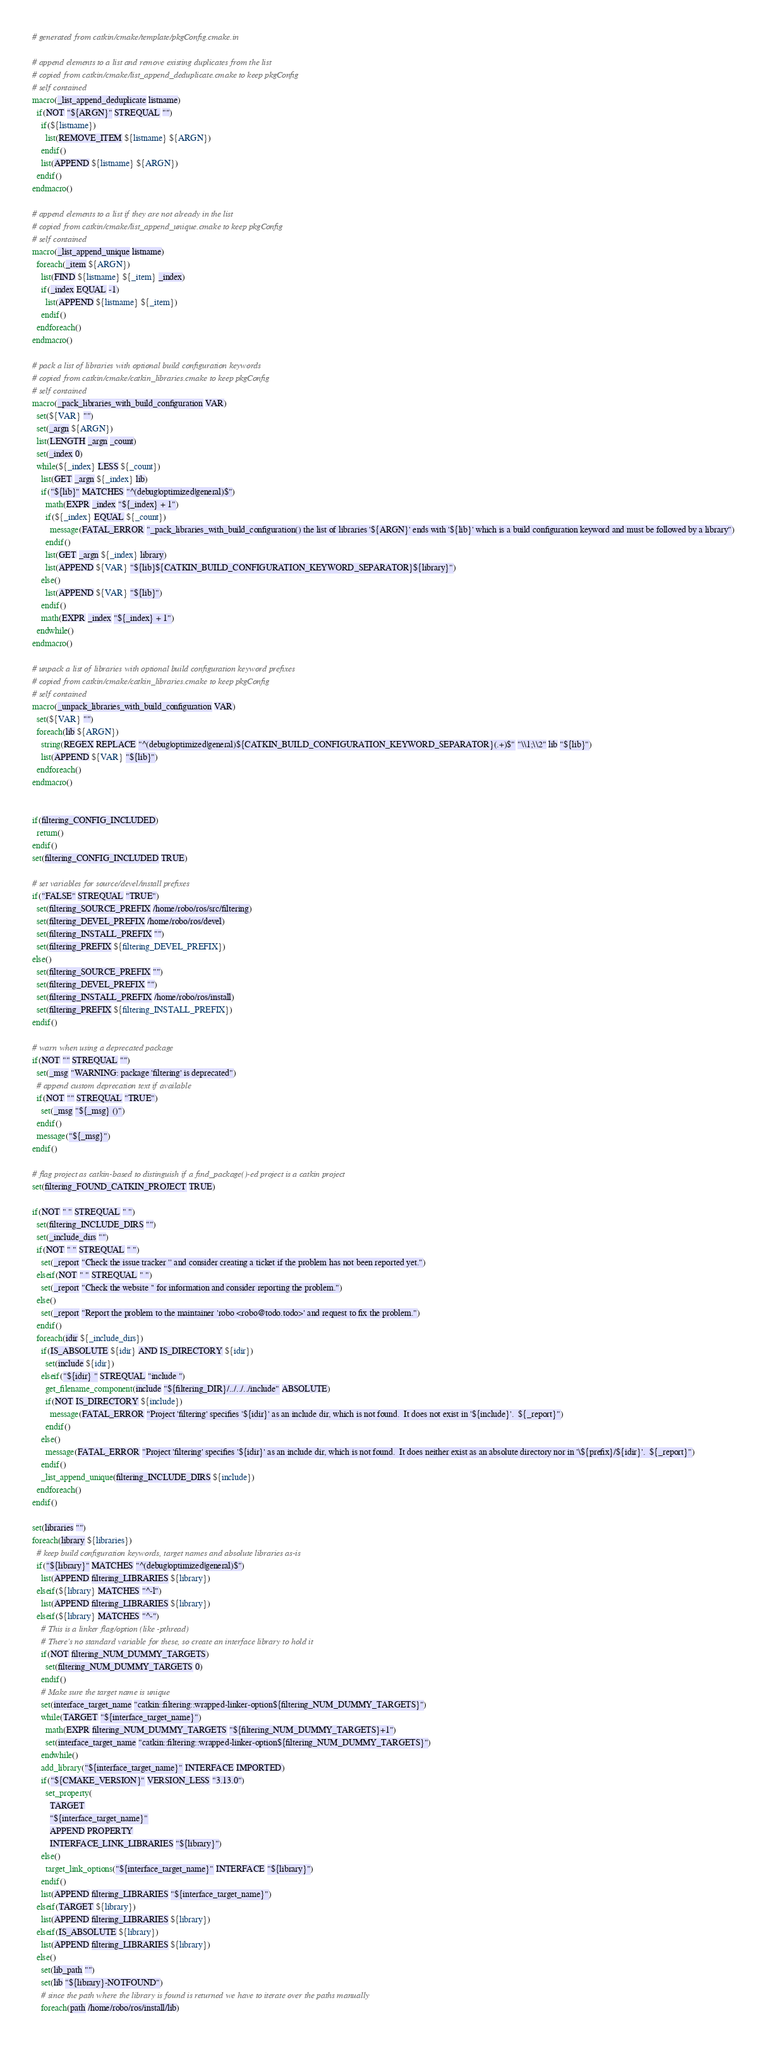Convert code to text. <code><loc_0><loc_0><loc_500><loc_500><_CMake_># generated from catkin/cmake/template/pkgConfig.cmake.in

# append elements to a list and remove existing duplicates from the list
# copied from catkin/cmake/list_append_deduplicate.cmake to keep pkgConfig
# self contained
macro(_list_append_deduplicate listname)
  if(NOT "${ARGN}" STREQUAL "")
    if(${listname})
      list(REMOVE_ITEM ${listname} ${ARGN})
    endif()
    list(APPEND ${listname} ${ARGN})
  endif()
endmacro()

# append elements to a list if they are not already in the list
# copied from catkin/cmake/list_append_unique.cmake to keep pkgConfig
# self contained
macro(_list_append_unique listname)
  foreach(_item ${ARGN})
    list(FIND ${listname} ${_item} _index)
    if(_index EQUAL -1)
      list(APPEND ${listname} ${_item})
    endif()
  endforeach()
endmacro()

# pack a list of libraries with optional build configuration keywords
# copied from catkin/cmake/catkin_libraries.cmake to keep pkgConfig
# self contained
macro(_pack_libraries_with_build_configuration VAR)
  set(${VAR} "")
  set(_argn ${ARGN})
  list(LENGTH _argn _count)
  set(_index 0)
  while(${_index} LESS ${_count})
    list(GET _argn ${_index} lib)
    if("${lib}" MATCHES "^(debug|optimized|general)$")
      math(EXPR _index "${_index} + 1")
      if(${_index} EQUAL ${_count})
        message(FATAL_ERROR "_pack_libraries_with_build_configuration() the list of libraries '${ARGN}' ends with '${lib}' which is a build configuration keyword and must be followed by a library")
      endif()
      list(GET _argn ${_index} library)
      list(APPEND ${VAR} "${lib}${CATKIN_BUILD_CONFIGURATION_KEYWORD_SEPARATOR}${library}")
    else()
      list(APPEND ${VAR} "${lib}")
    endif()
    math(EXPR _index "${_index} + 1")
  endwhile()
endmacro()

# unpack a list of libraries with optional build configuration keyword prefixes
# copied from catkin/cmake/catkin_libraries.cmake to keep pkgConfig
# self contained
macro(_unpack_libraries_with_build_configuration VAR)
  set(${VAR} "")
  foreach(lib ${ARGN})
    string(REGEX REPLACE "^(debug|optimized|general)${CATKIN_BUILD_CONFIGURATION_KEYWORD_SEPARATOR}(.+)$" "\\1;\\2" lib "${lib}")
    list(APPEND ${VAR} "${lib}")
  endforeach()
endmacro()


if(filtering_CONFIG_INCLUDED)
  return()
endif()
set(filtering_CONFIG_INCLUDED TRUE)

# set variables for source/devel/install prefixes
if("FALSE" STREQUAL "TRUE")
  set(filtering_SOURCE_PREFIX /home/robo/ros/src/filtering)
  set(filtering_DEVEL_PREFIX /home/robo/ros/devel)
  set(filtering_INSTALL_PREFIX "")
  set(filtering_PREFIX ${filtering_DEVEL_PREFIX})
else()
  set(filtering_SOURCE_PREFIX "")
  set(filtering_DEVEL_PREFIX "")
  set(filtering_INSTALL_PREFIX /home/robo/ros/install)
  set(filtering_PREFIX ${filtering_INSTALL_PREFIX})
endif()

# warn when using a deprecated package
if(NOT "" STREQUAL "")
  set(_msg "WARNING: package 'filtering' is deprecated")
  # append custom deprecation text if available
  if(NOT "" STREQUAL "TRUE")
    set(_msg "${_msg} ()")
  endif()
  message("${_msg}")
endif()

# flag project as catkin-based to distinguish if a find_package()-ed project is a catkin project
set(filtering_FOUND_CATKIN_PROJECT TRUE)

if(NOT " " STREQUAL " ")
  set(filtering_INCLUDE_DIRS "")
  set(_include_dirs "")
  if(NOT " " STREQUAL " ")
    set(_report "Check the issue tracker '' and consider creating a ticket if the problem has not been reported yet.")
  elseif(NOT " " STREQUAL " ")
    set(_report "Check the website '' for information and consider reporting the problem.")
  else()
    set(_report "Report the problem to the maintainer 'robo <robo@todo.todo>' and request to fix the problem.")
  endif()
  foreach(idir ${_include_dirs})
    if(IS_ABSOLUTE ${idir} AND IS_DIRECTORY ${idir})
      set(include ${idir})
    elseif("${idir} " STREQUAL "include ")
      get_filename_component(include "${filtering_DIR}/../../../include" ABSOLUTE)
      if(NOT IS_DIRECTORY ${include})
        message(FATAL_ERROR "Project 'filtering' specifies '${idir}' as an include dir, which is not found.  It does not exist in '${include}'.  ${_report}")
      endif()
    else()
      message(FATAL_ERROR "Project 'filtering' specifies '${idir}' as an include dir, which is not found.  It does neither exist as an absolute directory nor in '\${prefix}/${idir}'.  ${_report}")
    endif()
    _list_append_unique(filtering_INCLUDE_DIRS ${include})
  endforeach()
endif()

set(libraries "")
foreach(library ${libraries})
  # keep build configuration keywords, target names and absolute libraries as-is
  if("${library}" MATCHES "^(debug|optimized|general)$")
    list(APPEND filtering_LIBRARIES ${library})
  elseif(${library} MATCHES "^-l")
    list(APPEND filtering_LIBRARIES ${library})
  elseif(${library} MATCHES "^-")
    # This is a linker flag/option (like -pthread)
    # There's no standard variable for these, so create an interface library to hold it
    if(NOT filtering_NUM_DUMMY_TARGETS)
      set(filtering_NUM_DUMMY_TARGETS 0)
    endif()
    # Make sure the target name is unique
    set(interface_target_name "catkin::filtering::wrapped-linker-option${filtering_NUM_DUMMY_TARGETS}")
    while(TARGET "${interface_target_name}")
      math(EXPR filtering_NUM_DUMMY_TARGETS "${filtering_NUM_DUMMY_TARGETS}+1")
      set(interface_target_name "catkin::filtering::wrapped-linker-option${filtering_NUM_DUMMY_TARGETS}")
    endwhile()
    add_library("${interface_target_name}" INTERFACE IMPORTED)
    if("${CMAKE_VERSION}" VERSION_LESS "3.13.0")
      set_property(
        TARGET
        "${interface_target_name}"
        APPEND PROPERTY
        INTERFACE_LINK_LIBRARIES "${library}")
    else()
      target_link_options("${interface_target_name}" INTERFACE "${library}")
    endif()
    list(APPEND filtering_LIBRARIES "${interface_target_name}")
  elseif(TARGET ${library})
    list(APPEND filtering_LIBRARIES ${library})
  elseif(IS_ABSOLUTE ${library})
    list(APPEND filtering_LIBRARIES ${library})
  else()
    set(lib_path "")
    set(lib "${library}-NOTFOUND")
    # since the path where the library is found is returned we have to iterate over the paths manually
    foreach(path /home/robo/ros/install/lib)</code> 